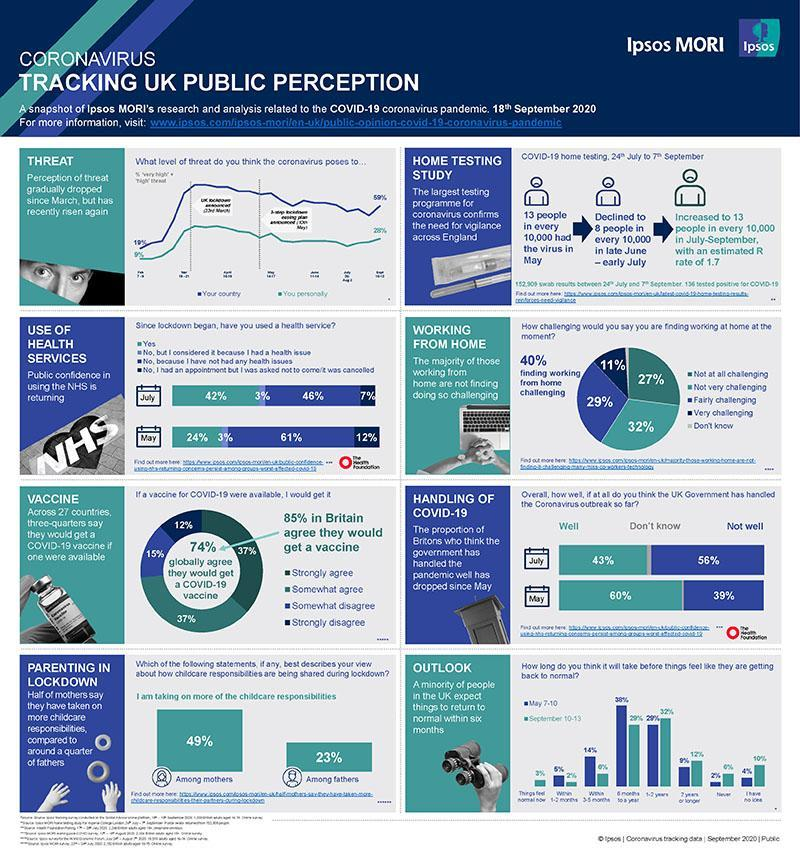What is the percentage of people of UK who did not use health services due to the lack of health issues in July?
Answer the question with a short phrase. 46 What percent of the people globally disagree on vaccination? 26% What percent of people who don't feel it challenging to work from home? 59% What is the percentage of people of UK who used health services in May? 24 What percent of people feel it challenging to work from home? 40% what is the decrease in number of people who had the virus in every 10000, from May to early July? 5 What percentage of people thinks that the UK government is not handling well the pandemic, in July? 56 What percentage of people thinks that the UK government is handling well the pandemic, in July? 43% What percentage of people thinks that the UK government is handling well the pandemic, in may? 60 What is the percentage of people of UK who did not use health services due to the lack of health issues in May? 61% What is the percentage of people of UK who used health services in July? 42 What percentage of people thinks that the UK government is not handling well the pandemic, in may? 39 who is taking up more parenting responsibilities in lockdown - mothers or fathers? mothers 